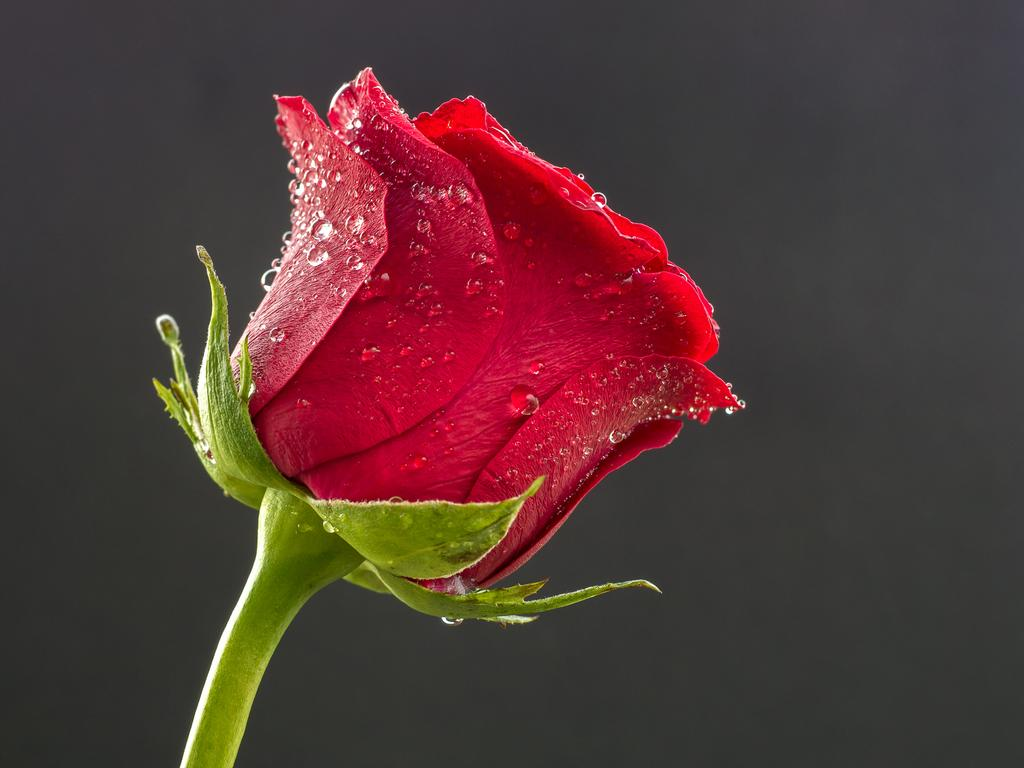What is the main subject of the picture? The main subject of the picture is a flower. What can be observed on the flower? The flower has water drops on it. What is the color of the background in the image? The background of the image is gray. How many brothers are depicted in the image? There are no people, including brothers, present in the image; it features a flower with water drops and a gray background. 